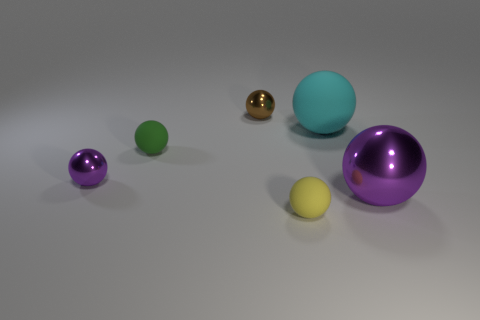Subtract all purple balls. How many balls are left? 4 Subtract all yellow spheres. How many spheres are left? 5 Subtract 3 balls. How many balls are left? 3 Subtract all cyan balls. Subtract all yellow cylinders. How many balls are left? 5 Add 1 big cyan matte objects. How many objects exist? 7 Subtract 0 red cylinders. How many objects are left? 6 Subtract all brown cylinders. Subtract all tiny purple spheres. How many objects are left? 5 Add 5 green rubber things. How many green rubber things are left? 6 Add 1 blue rubber cylinders. How many blue rubber cylinders exist? 1 